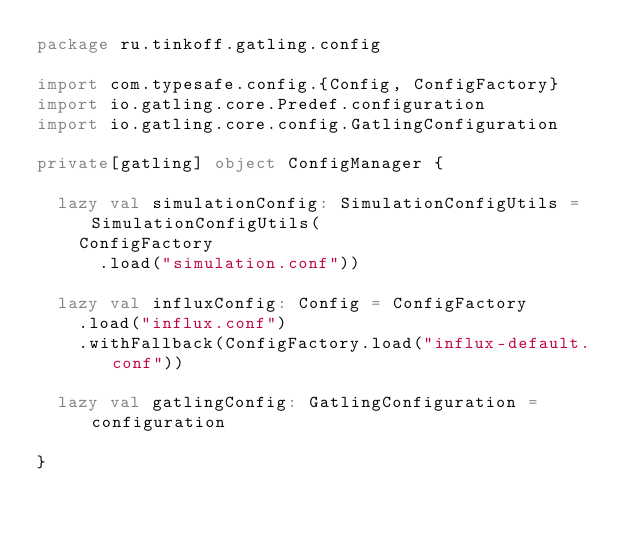<code> <loc_0><loc_0><loc_500><loc_500><_Scala_>package ru.tinkoff.gatling.config

import com.typesafe.config.{Config, ConfigFactory}
import io.gatling.core.Predef.configuration
import io.gatling.core.config.GatlingConfiguration

private[gatling] object ConfigManager {

  lazy val simulationConfig: SimulationConfigUtils = SimulationConfigUtils(
    ConfigFactory
      .load("simulation.conf"))

  lazy val influxConfig: Config = ConfigFactory
    .load("influx.conf")
    .withFallback(ConfigFactory.load("influx-default.conf"))

  lazy val gatlingConfig: GatlingConfiguration = configuration

}
</code> 